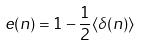Convert formula to latex. <formula><loc_0><loc_0><loc_500><loc_500>e ( n ) = 1 - \frac { 1 } { 2 } \langle \delta ( n ) \rangle</formula> 